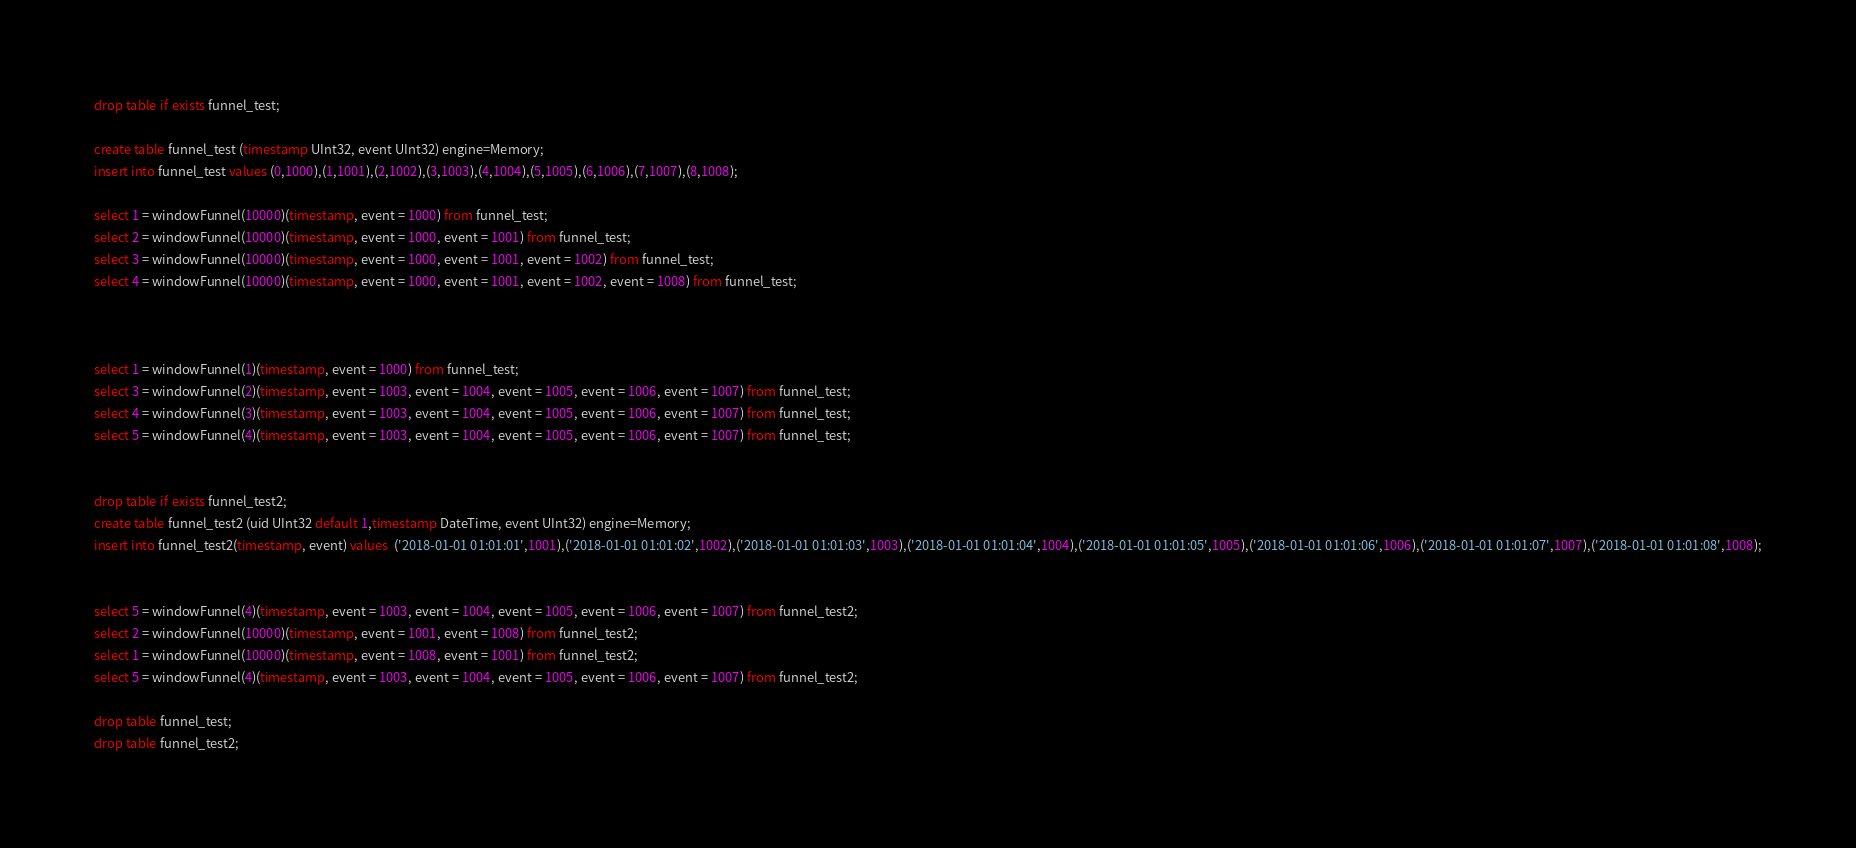<code> <loc_0><loc_0><loc_500><loc_500><_SQL_>drop table if exists funnel_test;

create table funnel_test (timestamp UInt32, event UInt32) engine=Memory;
insert into funnel_test values (0,1000),(1,1001),(2,1002),(3,1003),(4,1004),(5,1005),(6,1006),(7,1007),(8,1008);

select 1 = windowFunnel(10000)(timestamp, event = 1000) from funnel_test;
select 2 = windowFunnel(10000)(timestamp, event = 1000, event = 1001) from funnel_test;
select 3 = windowFunnel(10000)(timestamp, event = 1000, event = 1001, event = 1002) from funnel_test;
select 4 = windowFunnel(10000)(timestamp, event = 1000, event = 1001, event = 1002, event = 1008) from funnel_test;



select 1 = windowFunnel(1)(timestamp, event = 1000) from funnel_test;
select 3 = windowFunnel(2)(timestamp, event = 1003, event = 1004, event = 1005, event = 1006, event = 1007) from funnel_test;
select 4 = windowFunnel(3)(timestamp, event = 1003, event = 1004, event = 1005, event = 1006, event = 1007) from funnel_test;
select 5 = windowFunnel(4)(timestamp, event = 1003, event = 1004, event = 1005, event = 1006, event = 1007) from funnel_test;


drop table if exists funnel_test2;
create table funnel_test2 (uid UInt32 default 1,timestamp DateTime, event UInt32) engine=Memory;
insert into funnel_test2(timestamp, event) values  ('2018-01-01 01:01:01',1001),('2018-01-01 01:01:02',1002),('2018-01-01 01:01:03',1003),('2018-01-01 01:01:04',1004),('2018-01-01 01:01:05',1005),('2018-01-01 01:01:06',1006),('2018-01-01 01:01:07',1007),('2018-01-01 01:01:08',1008);


select 5 = windowFunnel(4)(timestamp, event = 1003, event = 1004, event = 1005, event = 1006, event = 1007) from funnel_test2;
select 2 = windowFunnel(10000)(timestamp, event = 1001, event = 1008) from funnel_test2;
select 1 = windowFunnel(10000)(timestamp, event = 1008, event = 1001) from funnel_test2;
select 5 = windowFunnel(4)(timestamp, event = 1003, event = 1004, event = 1005, event = 1006, event = 1007) from funnel_test2;

drop table funnel_test;
drop table funnel_test2;
</code> 